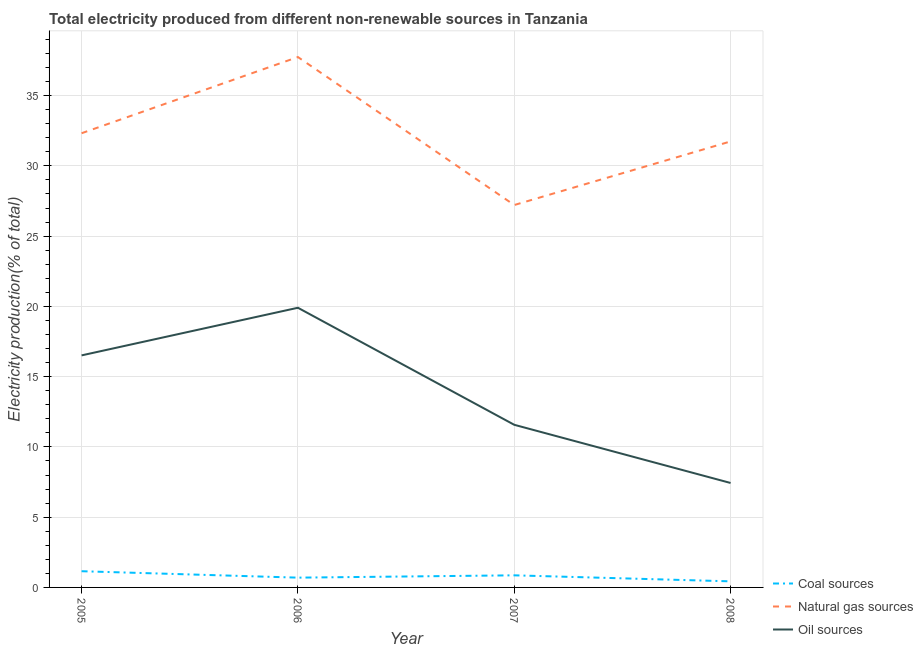Does the line corresponding to percentage of electricity produced by natural gas intersect with the line corresponding to percentage of electricity produced by oil sources?
Offer a terse response. No. Is the number of lines equal to the number of legend labels?
Provide a succinct answer. Yes. What is the percentage of electricity produced by natural gas in 2008?
Provide a short and direct response. 31.74. Across all years, what is the maximum percentage of electricity produced by natural gas?
Your response must be concise. 37.74. Across all years, what is the minimum percentage of electricity produced by natural gas?
Keep it short and to the point. 27.21. In which year was the percentage of electricity produced by oil sources maximum?
Make the answer very short. 2006. What is the total percentage of electricity produced by natural gas in the graph?
Your response must be concise. 129.01. What is the difference between the percentage of electricity produced by oil sources in 2005 and that in 2007?
Offer a terse response. 4.94. What is the difference between the percentage of electricity produced by oil sources in 2008 and the percentage of electricity produced by coal in 2006?
Ensure brevity in your answer.  6.74. What is the average percentage of electricity produced by natural gas per year?
Your answer should be very brief. 32.25. In the year 2008, what is the difference between the percentage of electricity produced by coal and percentage of electricity produced by oil sources?
Provide a succinct answer. -7. What is the ratio of the percentage of electricity produced by coal in 2007 to that in 2008?
Offer a terse response. 1.99. Is the percentage of electricity produced by natural gas in 2006 less than that in 2007?
Offer a terse response. No. Is the difference between the percentage of electricity produced by coal in 2006 and 2007 greater than the difference between the percentage of electricity produced by oil sources in 2006 and 2007?
Ensure brevity in your answer.  No. What is the difference between the highest and the second highest percentage of electricity produced by coal?
Provide a short and direct response. 0.29. What is the difference between the highest and the lowest percentage of electricity produced by coal?
Make the answer very short. 0.72. Is the sum of the percentage of electricity produced by oil sources in 2005 and 2007 greater than the maximum percentage of electricity produced by natural gas across all years?
Offer a very short reply. No. Is it the case that in every year, the sum of the percentage of electricity produced by coal and percentage of electricity produced by natural gas is greater than the percentage of electricity produced by oil sources?
Keep it short and to the point. Yes. Does the percentage of electricity produced by oil sources monotonically increase over the years?
Provide a short and direct response. No. How many lines are there?
Your answer should be compact. 3. How many years are there in the graph?
Your answer should be very brief. 4. What is the difference between two consecutive major ticks on the Y-axis?
Ensure brevity in your answer.  5. Where does the legend appear in the graph?
Give a very brief answer. Bottom right. How many legend labels are there?
Your answer should be very brief. 3. How are the legend labels stacked?
Your answer should be compact. Vertical. What is the title of the graph?
Provide a succinct answer. Total electricity produced from different non-renewable sources in Tanzania. What is the label or title of the X-axis?
Your answer should be very brief. Year. What is the Electricity production(% of total) in Coal sources in 2005?
Offer a very short reply. 1.15. What is the Electricity production(% of total) in Natural gas sources in 2005?
Offer a very short reply. 32.32. What is the Electricity production(% of total) of Oil sources in 2005?
Your answer should be compact. 16.51. What is the Electricity production(% of total) in Coal sources in 2006?
Offer a terse response. 0.7. What is the Electricity production(% of total) of Natural gas sources in 2006?
Make the answer very short. 37.74. What is the Electricity production(% of total) of Oil sources in 2006?
Provide a succinct answer. 19.9. What is the Electricity production(% of total) of Coal sources in 2007?
Provide a short and direct response. 0.86. What is the Electricity production(% of total) in Natural gas sources in 2007?
Your answer should be compact. 27.21. What is the Electricity production(% of total) in Oil sources in 2007?
Make the answer very short. 11.57. What is the Electricity production(% of total) in Coal sources in 2008?
Keep it short and to the point. 0.43. What is the Electricity production(% of total) of Natural gas sources in 2008?
Keep it short and to the point. 31.74. What is the Electricity production(% of total) of Oil sources in 2008?
Offer a very short reply. 7.43. Across all years, what is the maximum Electricity production(% of total) of Coal sources?
Your response must be concise. 1.15. Across all years, what is the maximum Electricity production(% of total) in Natural gas sources?
Provide a short and direct response. 37.74. Across all years, what is the maximum Electricity production(% of total) in Oil sources?
Offer a terse response. 19.9. Across all years, what is the minimum Electricity production(% of total) in Coal sources?
Your response must be concise. 0.43. Across all years, what is the minimum Electricity production(% of total) in Natural gas sources?
Your answer should be compact. 27.21. Across all years, what is the minimum Electricity production(% of total) of Oil sources?
Your response must be concise. 7.43. What is the total Electricity production(% of total) of Coal sources in the graph?
Your response must be concise. 3.14. What is the total Electricity production(% of total) of Natural gas sources in the graph?
Ensure brevity in your answer.  129.01. What is the total Electricity production(% of total) in Oil sources in the graph?
Provide a short and direct response. 55.42. What is the difference between the Electricity production(% of total) in Coal sources in 2005 and that in 2006?
Offer a terse response. 0.46. What is the difference between the Electricity production(% of total) of Natural gas sources in 2005 and that in 2006?
Make the answer very short. -5.42. What is the difference between the Electricity production(% of total) in Oil sources in 2005 and that in 2006?
Offer a very short reply. -3.39. What is the difference between the Electricity production(% of total) of Coal sources in 2005 and that in 2007?
Make the answer very short. 0.29. What is the difference between the Electricity production(% of total) of Natural gas sources in 2005 and that in 2007?
Your answer should be compact. 5.11. What is the difference between the Electricity production(% of total) in Oil sources in 2005 and that in 2007?
Your response must be concise. 4.94. What is the difference between the Electricity production(% of total) of Coal sources in 2005 and that in 2008?
Give a very brief answer. 0.72. What is the difference between the Electricity production(% of total) of Natural gas sources in 2005 and that in 2008?
Your answer should be very brief. 0.58. What is the difference between the Electricity production(% of total) of Oil sources in 2005 and that in 2008?
Offer a terse response. 9.08. What is the difference between the Electricity production(% of total) of Coal sources in 2006 and that in 2007?
Give a very brief answer. -0.16. What is the difference between the Electricity production(% of total) in Natural gas sources in 2006 and that in 2007?
Your answer should be compact. 10.53. What is the difference between the Electricity production(% of total) of Oil sources in 2006 and that in 2007?
Make the answer very short. 8.33. What is the difference between the Electricity production(% of total) of Coal sources in 2006 and that in 2008?
Ensure brevity in your answer.  0.26. What is the difference between the Electricity production(% of total) of Natural gas sources in 2006 and that in 2008?
Offer a terse response. 6.01. What is the difference between the Electricity production(% of total) of Oil sources in 2006 and that in 2008?
Your answer should be compact. 12.47. What is the difference between the Electricity production(% of total) in Coal sources in 2007 and that in 2008?
Make the answer very short. 0.43. What is the difference between the Electricity production(% of total) in Natural gas sources in 2007 and that in 2008?
Keep it short and to the point. -4.53. What is the difference between the Electricity production(% of total) of Oil sources in 2007 and that in 2008?
Your answer should be compact. 4.14. What is the difference between the Electricity production(% of total) in Coal sources in 2005 and the Electricity production(% of total) in Natural gas sources in 2006?
Provide a short and direct response. -36.59. What is the difference between the Electricity production(% of total) in Coal sources in 2005 and the Electricity production(% of total) in Oil sources in 2006?
Your response must be concise. -18.75. What is the difference between the Electricity production(% of total) in Natural gas sources in 2005 and the Electricity production(% of total) in Oil sources in 2006?
Ensure brevity in your answer.  12.42. What is the difference between the Electricity production(% of total) in Coal sources in 2005 and the Electricity production(% of total) in Natural gas sources in 2007?
Give a very brief answer. -26.06. What is the difference between the Electricity production(% of total) of Coal sources in 2005 and the Electricity production(% of total) of Oil sources in 2007?
Make the answer very short. -10.42. What is the difference between the Electricity production(% of total) of Natural gas sources in 2005 and the Electricity production(% of total) of Oil sources in 2007?
Keep it short and to the point. 20.75. What is the difference between the Electricity production(% of total) of Coal sources in 2005 and the Electricity production(% of total) of Natural gas sources in 2008?
Your response must be concise. -30.58. What is the difference between the Electricity production(% of total) in Coal sources in 2005 and the Electricity production(% of total) in Oil sources in 2008?
Make the answer very short. -6.28. What is the difference between the Electricity production(% of total) in Natural gas sources in 2005 and the Electricity production(% of total) in Oil sources in 2008?
Offer a very short reply. 24.89. What is the difference between the Electricity production(% of total) in Coal sources in 2006 and the Electricity production(% of total) in Natural gas sources in 2007?
Provide a short and direct response. -26.52. What is the difference between the Electricity production(% of total) of Coal sources in 2006 and the Electricity production(% of total) of Oil sources in 2007?
Offer a very short reply. -10.88. What is the difference between the Electricity production(% of total) in Natural gas sources in 2006 and the Electricity production(% of total) in Oil sources in 2007?
Ensure brevity in your answer.  26.17. What is the difference between the Electricity production(% of total) of Coal sources in 2006 and the Electricity production(% of total) of Natural gas sources in 2008?
Ensure brevity in your answer.  -31.04. What is the difference between the Electricity production(% of total) in Coal sources in 2006 and the Electricity production(% of total) in Oil sources in 2008?
Ensure brevity in your answer.  -6.74. What is the difference between the Electricity production(% of total) in Natural gas sources in 2006 and the Electricity production(% of total) in Oil sources in 2008?
Provide a short and direct response. 30.31. What is the difference between the Electricity production(% of total) in Coal sources in 2007 and the Electricity production(% of total) in Natural gas sources in 2008?
Keep it short and to the point. -30.88. What is the difference between the Electricity production(% of total) in Coal sources in 2007 and the Electricity production(% of total) in Oil sources in 2008?
Your answer should be very brief. -6.57. What is the difference between the Electricity production(% of total) in Natural gas sources in 2007 and the Electricity production(% of total) in Oil sources in 2008?
Your response must be concise. 19.78. What is the average Electricity production(% of total) in Coal sources per year?
Offer a terse response. 0.79. What is the average Electricity production(% of total) in Natural gas sources per year?
Your answer should be compact. 32.25. What is the average Electricity production(% of total) of Oil sources per year?
Keep it short and to the point. 13.85. In the year 2005, what is the difference between the Electricity production(% of total) of Coal sources and Electricity production(% of total) of Natural gas sources?
Keep it short and to the point. -31.17. In the year 2005, what is the difference between the Electricity production(% of total) in Coal sources and Electricity production(% of total) in Oil sources?
Make the answer very short. -15.36. In the year 2005, what is the difference between the Electricity production(% of total) in Natural gas sources and Electricity production(% of total) in Oil sources?
Offer a very short reply. 15.81. In the year 2006, what is the difference between the Electricity production(% of total) in Coal sources and Electricity production(% of total) in Natural gas sources?
Provide a succinct answer. -37.05. In the year 2006, what is the difference between the Electricity production(% of total) of Coal sources and Electricity production(% of total) of Oil sources?
Your answer should be compact. -19.21. In the year 2006, what is the difference between the Electricity production(% of total) in Natural gas sources and Electricity production(% of total) in Oil sources?
Your answer should be compact. 17.84. In the year 2007, what is the difference between the Electricity production(% of total) of Coal sources and Electricity production(% of total) of Natural gas sources?
Your response must be concise. -26.35. In the year 2007, what is the difference between the Electricity production(% of total) of Coal sources and Electricity production(% of total) of Oil sources?
Make the answer very short. -10.71. In the year 2007, what is the difference between the Electricity production(% of total) of Natural gas sources and Electricity production(% of total) of Oil sources?
Your answer should be very brief. 15.64. In the year 2008, what is the difference between the Electricity production(% of total) in Coal sources and Electricity production(% of total) in Natural gas sources?
Ensure brevity in your answer.  -31.3. In the year 2008, what is the difference between the Electricity production(% of total) of Coal sources and Electricity production(% of total) of Oil sources?
Ensure brevity in your answer.  -7. In the year 2008, what is the difference between the Electricity production(% of total) of Natural gas sources and Electricity production(% of total) of Oil sources?
Your response must be concise. 24.3. What is the ratio of the Electricity production(% of total) of Coal sources in 2005 to that in 2006?
Your answer should be compact. 1.66. What is the ratio of the Electricity production(% of total) of Natural gas sources in 2005 to that in 2006?
Your response must be concise. 0.86. What is the ratio of the Electricity production(% of total) of Oil sources in 2005 to that in 2006?
Provide a short and direct response. 0.83. What is the ratio of the Electricity production(% of total) in Coal sources in 2005 to that in 2007?
Provide a succinct answer. 1.34. What is the ratio of the Electricity production(% of total) in Natural gas sources in 2005 to that in 2007?
Your response must be concise. 1.19. What is the ratio of the Electricity production(% of total) of Oil sources in 2005 to that in 2007?
Ensure brevity in your answer.  1.43. What is the ratio of the Electricity production(% of total) in Coal sources in 2005 to that in 2008?
Offer a very short reply. 2.66. What is the ratio of the Electricity production(% of total) in Natural gas sources in 2005 to that in 2008?
Provide a short and direct response. 1.02. What is the ratio of the Electricity production(% of total) of Oil sources in 2005 to that in 2008?
Your answer should be very brief. 2.22. What is the ratio of the Electricity production(% of total) in Coal sources in 2006 to that in 2007?
Your answer should be very brief. 0.81. What is the ratio of the Electricity production(% of total) of Natural gas sources in 2006 to that in 2007?
Ensure brevity in your answer.  1.39. What is the ratio of the Electricity production(% of total) in Oil sources in 2006 to that in 2007?
Provide a short and direct response. 1.72. What is the ratio of the Electricity production(% of total) in Coal sources in 2006 to that in 2008?
Offer a very short reply. 1.61. What is the ratio of the Electricity production(% of total) in Natural gas sources in 2006 to that in 2008?
Make the answer very short. 1.19. What is the ratio of the Electricity production(% of total) of Oil sources in 2006 to that in 2008?
Keep it short and to the point. 2.68. What is the ratio of the Electricity production(% of total) in Coal sources in 2007 to that in 2008?
Your response must be concise. 1.99. What is the ratio of the Electricity production(% of total) in Natural gas sources in 2007 to that in 2008?
Offer a terse response. 0.86. What is the ratio of the Electricity production(% of total) of Oil sources in 2007 to that in 2008?
Provide a short and direct response. 1.56. What is the difference between the highest and the second highest Electricity production(% of total) of Coal sources?
Ensure brevity in your answer.  0.29. What is the difference between the highest and the second highest Electricity production(% of total) of Natural gas sources?
Make the answer very short. 5.42. What is the difference between the highest and the second highest Electricity production(% of total) in Oil sources?
Keep it short and to the point. 3.39. What is the difference between the highest and the lowest Electricity production(% of total) in Coal sources?
Your response must be concise. 0.72. What is the difference between the highest and the lowest Electricity production(% of total) in Natural gas sources?
Keep it short and to the point. 10.53. What is the difference between the highest and the lowest Electricity production(% of total) in Oil sources?
Offer a terse response. 12.47. 